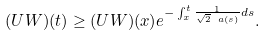<formula> <loc_0><loc_0><loc_500><loc_500>( U W ) ( t ) \geq ( U W ) ( x ) e ^ { - \int _ { x } ^ { t } \frac { 1 } { \sqrt { 2 } \ a ( s ) } d s } .</formula> 